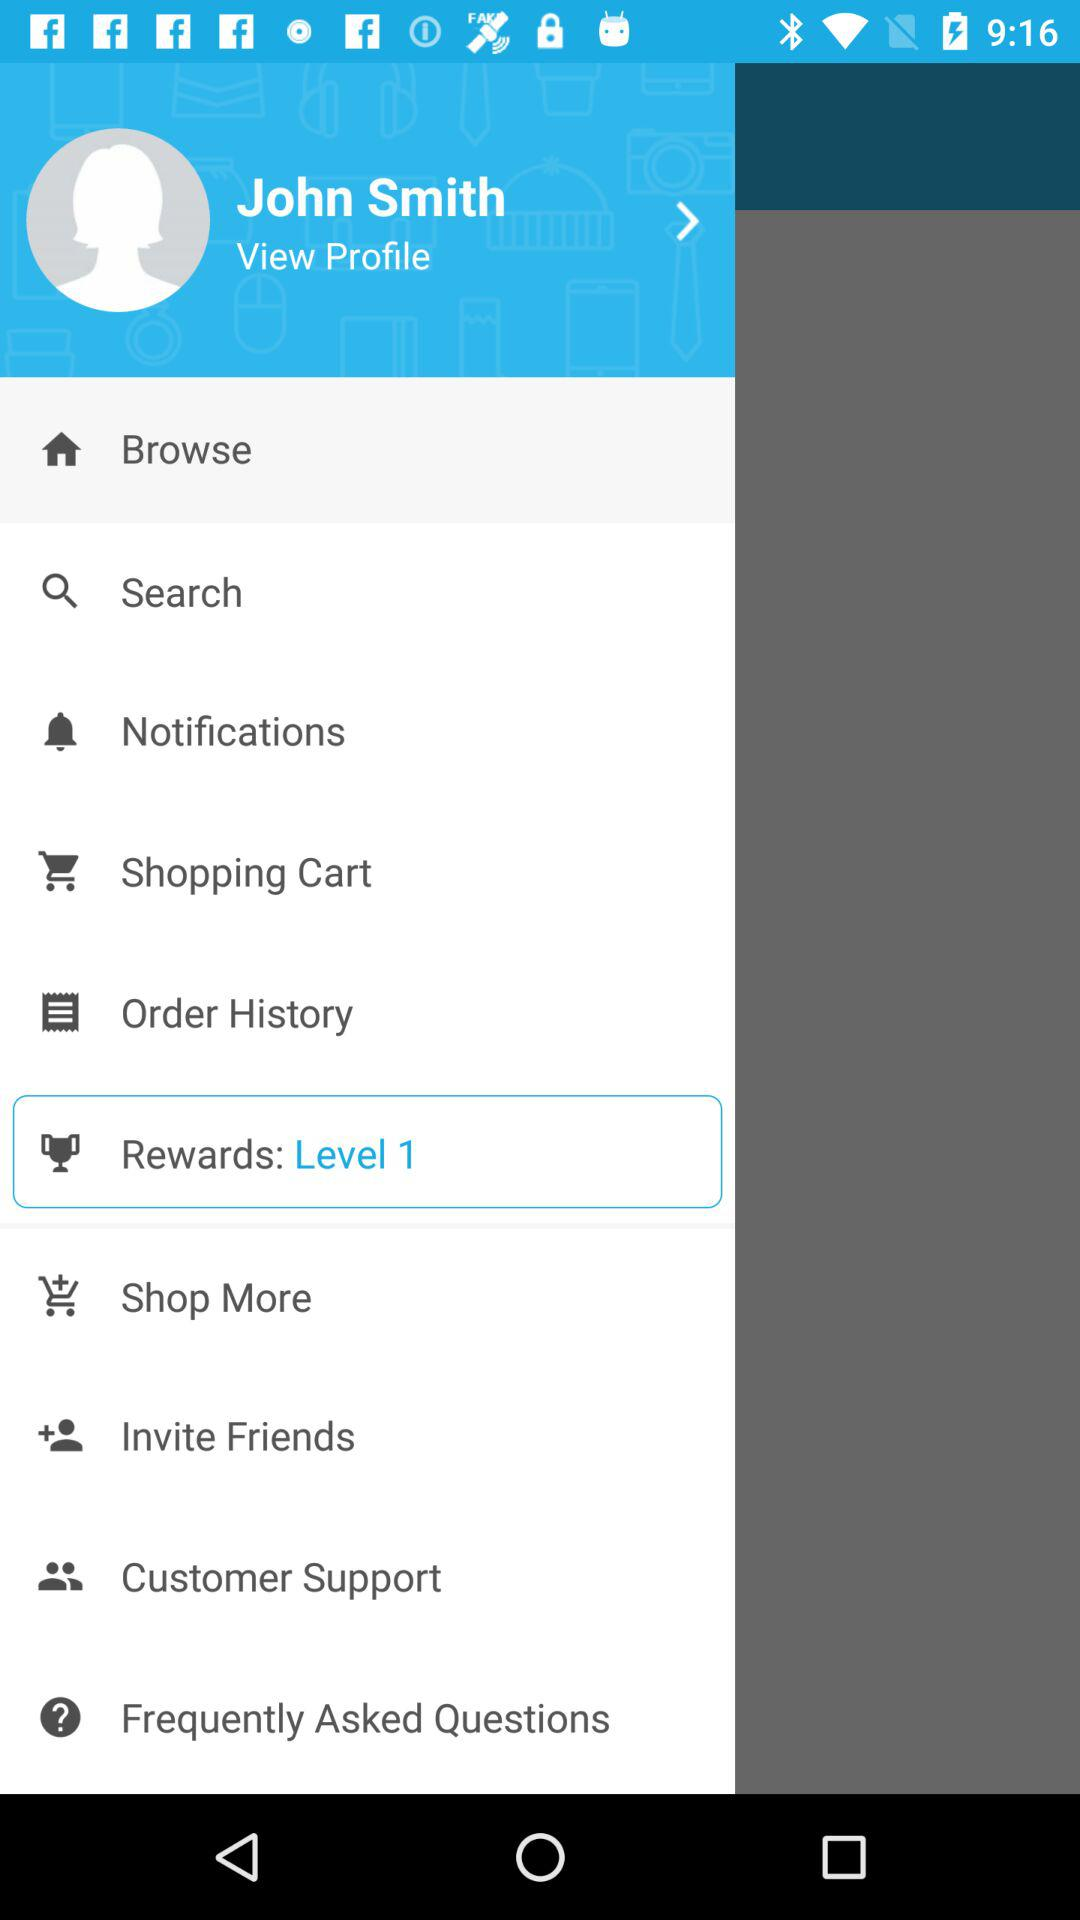What is the user name? The user name is John Smith. 